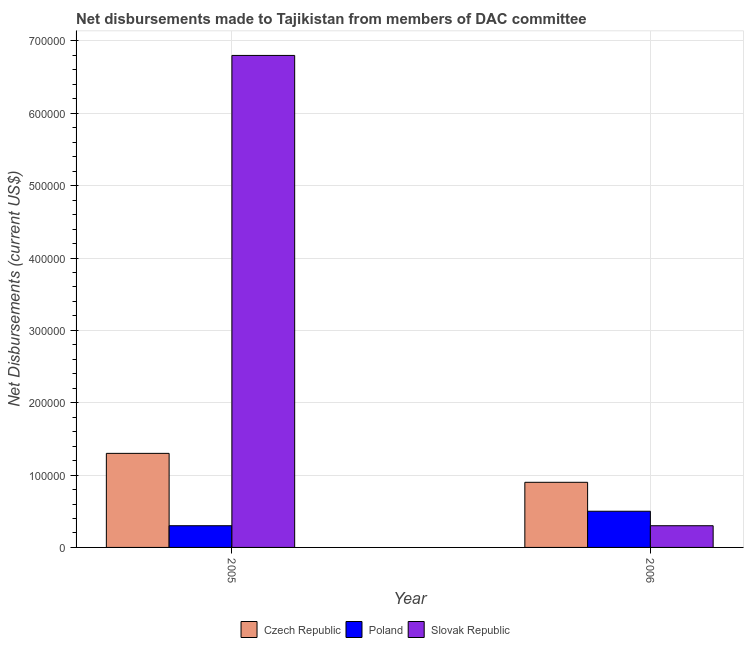How many groups of bars are there?
Your answer should be compact. 2. Are the number of bars on each tick of the X-axis equal?
Your answer should be very brief. Yes. How many bars are there on the 2nd tick from the left?
Offer a very short reply. 3. What is the label of the 1st group of bars from the left?
Provide a succinct answer. 2005. In how many cases, is the number of bars for a given year not equal to the number of legend labels?
Your answer should be compact. 0. What is the net disbursements made by poland in 2006?
Ensure brevity in your answer.  5.00e+04. Across all years, what is the maximum net disbursements made by slovak republic?
Provide a succinct answer. 6.80e+05. Across all years, what is the minimum net disbursements made by poland?
Your response must be concise. 3.00e+04. What is the total net disbursements made by slovak republic in the graph?
Make the answer very short. 7.10e+05. What is the difference between the net disbursements made by czech republic in 2005 and that in 2006?
Ensure brevity in your answer.  4.00e+04. What is the difference between the net disbursements made by slovak republic in 2006 and the net disbursements made by czech republic in 2005?
Offer a very short reply. -6.50e+05. What is the average net disbursements made by czech republic per year?
Offer a terse response. 1.10e+05. What is the ratio of the net disbursements made by slovak republic in 2005 to that in 2006?
Offer a very short reply. 22.67. Is the net disbursements made by poland in 2005 less than that in 2006?
Offer a very short reply. Yes. What does the 1st bar from the right in 2005 represents?
Your answer should be compact. Slovak Republic. Are all the bars in the graph horizontal?
Give a very brief answer. No. How many years are there in the graph?
Make the answer very short. 2. What is the difference between two consecutive major ticks on the Y-axis?
Your answer should be very brief. 1.00e+05. Are the values on the major ticks of Y-axis written in scientific E-notation?
Your answer should be very brief. No. Does the graph contain any zero values?
Give a very brief answer. No. Does the graph contain grids?
Keep it short and to the point. Yes. How are the legend labels stacked?
Your answer should be compact. Horizontal. What is the title of the graph?
Keep it short and to the point. Net disbursements made to Tajikistan from members of DAC committee. What is the label or title of the X-axis?
Offer a terse response. Year. What is the label or title of the Y-axis?
Keep it short and to the point. Net Disbursements (current US$). What is the Net Disbursements (current US$) in Poland in 2005?
Ensure brevity in your answer.  3.00e+04. What is the Net Disbursements (current US$) of Slovak Republic in 2005?
Your answer should be very brief. 6.80e+05. What is the Net Disbursements (current US$) in Czech Republic in 2006?
Offer a terse response. 9.00e+04. Across all years, what is the maximum Net Disbursements (current US$) of Poland?
Provide a short and direct response. 5.00e+04. Across all years, what is the maximum Net Disbursements (current US$) in Slovak Republic?
Your answer should be compact. 6.80e+05. Across all years, what is the minimum Net Disbursements (current US$) of Poland?
Your response must be concise. 3.00e+04. Across all years, what is the minimum Net Disbursements (current US$) in Slovak Republic?
Ensure brevity in your answer.  3.00e+04. What is the total Net Disbursements (current US$) of Czech Republic in the graph?
Keep it short and to the point. 2.20e+05. What is the total Net Disbursements (current US$) of Slovak Republic in the graph?
Provide a succinct answer. 7.10e+05. What is the difference between the Net Disbursements (current US$) of Czech Republic in 2005 and that in 2006?
Ensure brevity in your answer.  4.00e+04. What is the difference between the Net Disbursements (current US$) in Slovak Republic in 2005 and that in 2006?
Provide a succinct answer. 6.50e+05. What is the difference between the Net Disbursements (current US$) in Czech Republic in 2005 and the Net Disbursements (current US$) in Poland in 2006?
Your answer should be very brief. 8.00e+04. What is the difference between the Net Disbursements (current US$) in Czech Republic in 2005 and the Net Disbursements (current US$) in Slovak Republic in 2006?
Offer a very short reply. 1.00e+05. What is the difference between the Net Disbursements (current US$) of Poland in 2005 and the Net Disbursements (current US$) of Slovak Republic in 2006?
Provide a short and direct response. 0. What is the average Net Disbursements (current US$) in Slovak Republic per year?
Provide a short and direct response. 3.55e+05. In the year 2005, what is the difference between the Net Disbursements (current US$) of Czech Republic and Net Disbursements (current US$) of Slovak Republic?
Provide a succinct answer. -5.50e+05. In the year 2005, what is the difference between the Net Disbursements (current US$) of Poland and Net Disbursements (current US$) of Slovak Republic?
Make the answer very short. -6.50e+05. In the year 2006, what is the difference between the Net Disbursements (current US$) of Poland and Net Disbursements (current US$) of Slovak Republic?
Offer a terse response. 2.00e+04. What is the ratio of the Net Disbursements (current US$) in Czech Republic in 2005 to that in 2006?
Offer a very short reply. 1.44. What is the ratio of the Net Disbursements (current US$) in Slovak Republic in 2005 to that in 2006?
Give a very brief answer. 22.67. What is the difference between the highest and the second highest Net Disbursements (current US$) of Czech Republic?
Make the answer very short. 4.00e+04. What is the difference between the highest and the second highest Net Disbursements (current US$) of Slovak Republic?
Your answer should be very brief. 6.50e+05. What is the difference between the highest and the lowest Net Disbursements (current US$) in Poland?
Your answer should be compact. 2.00e+04. What is the difference between the highest and the lowest Net Disbursements (current US$) in Slovak Republic?
Give a very brief answer. 6.50e+05. 